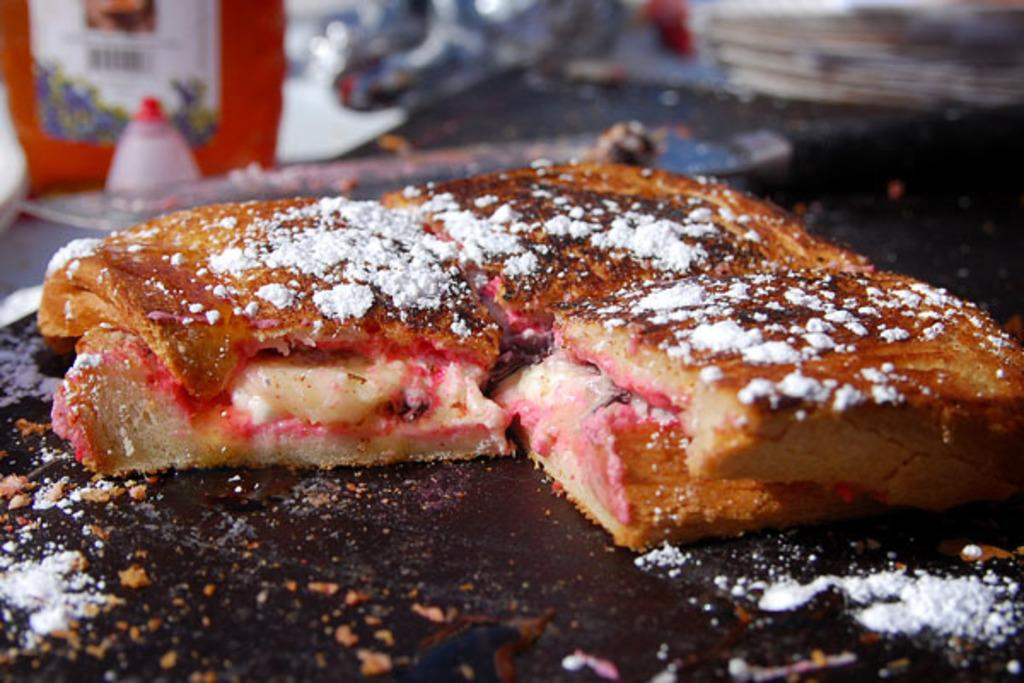What can be seen in the image related to food? There is food in the image. What piece of furniture is present in the image? There is a table in the image. What type of bridge can be seen in the image? There is no bridge present in the image; it only features food and a table. How many people are involved in the fight depicted in the image? There is no fight depicted in the image; it only features food and a table. 